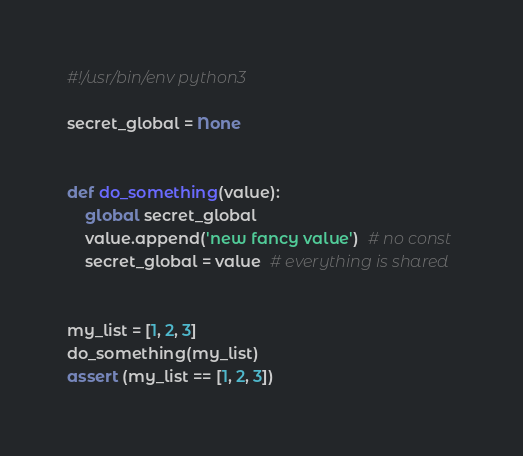Convert code to text. <code><loc_0><loc_0><loc_500><loc_500><_Python_>#!/usr/bin/env python3

secret_global = None


def do_something(value):
    global secret_global
    value.append('new fancy value')  # no const
    secret_global = value  # everything is shared


my_list = [1, 2, 3]
do_something(my_list)
assert (my_list == [1, 2, 3])
</code> 